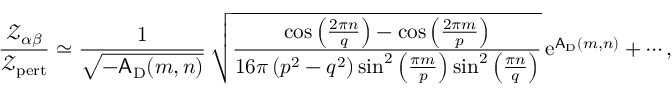<formula> <loc_0><loc_0><loc_500><loc_500>\frac { { \ m a t h s c r Z } _ { \alpha \beta } } { { \ m a t h s c r Z } _ { p e r t } } \simeq \frac { 1 } { \sqrt { - A _ { D } ( m , n ) } } \, \sqrt { \frac { \cos \left ( \frac { 2 \pi n } { q } \right ) - \cos \left ( \frac { 2 \pi m } { p } \right ) } { 1 6 \pi \left ( p ^ { 2 } - q ^ { 2 } \right ) \sin ^ { 2 } \left ( \frac { \pi m } { p } \right ) \sin ^ { 2 } \left ( \frac { \pi n } { q } \right ) } } \, { e } ^ { A _ { D } ( m , n ) } + \cdots ,</formula> 